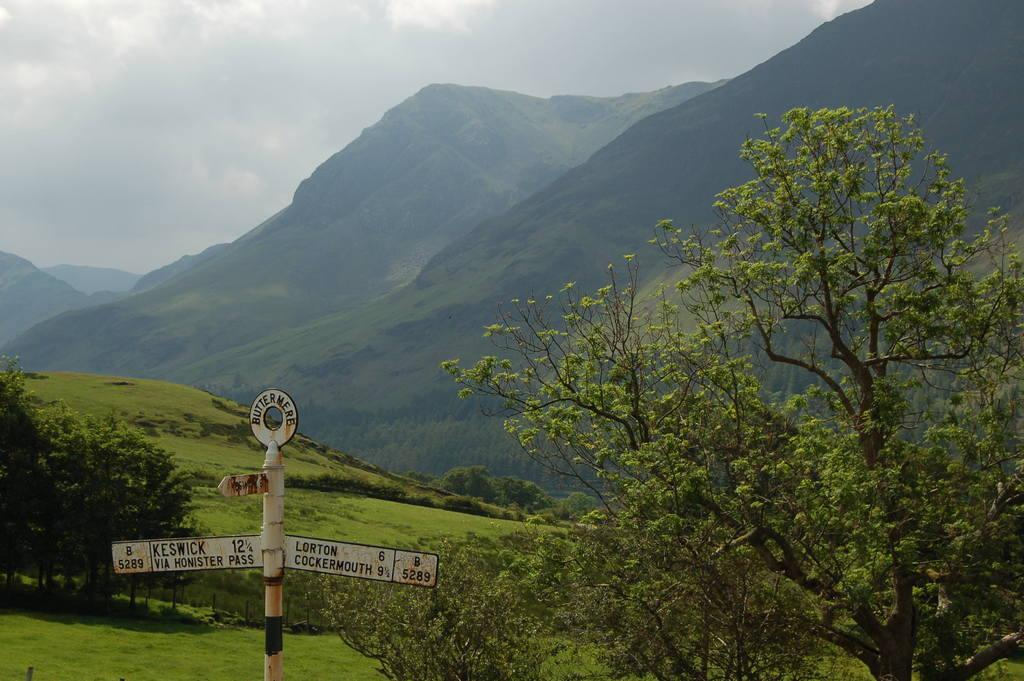What is attached to the pole in the image? There are name boards attached to a pole in the image. What type of natural environment is depicted in the image? The image features trees, mountains, and grass. What can be seen in the background of the image? The sky with clouds is visible in the background of the image. What type of appliance is being used to turn the pages in the image? There is no appliance or pages present in the image; it features name boards, trees, mountains, grass, and a sky with clouds. 